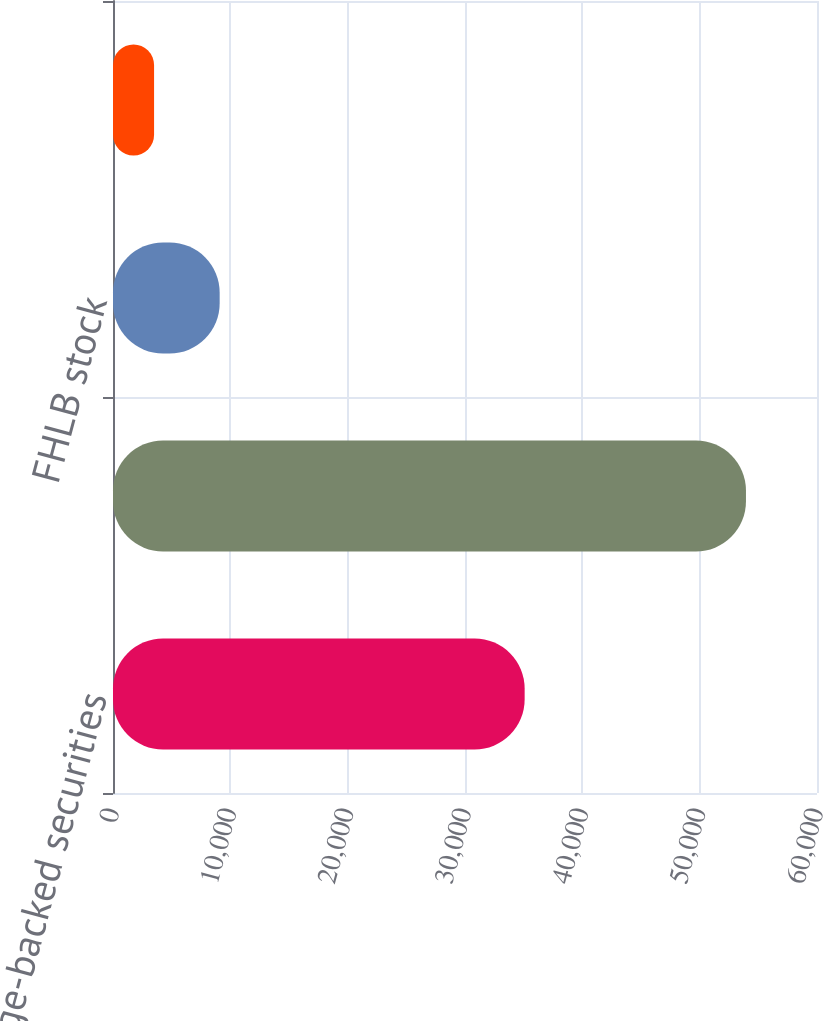Convert chart. <chart><loc_0><loc_0><loc_500><loc_500><bar_chart><fcel>Mortgage-backed securities<fcel>Federal funds sold<fcel>FHLB stock<fcel>Trust preferred security<nl><fcel>35084<fcel>53946<fcel>9091<fcel>3500<nl></chart> 